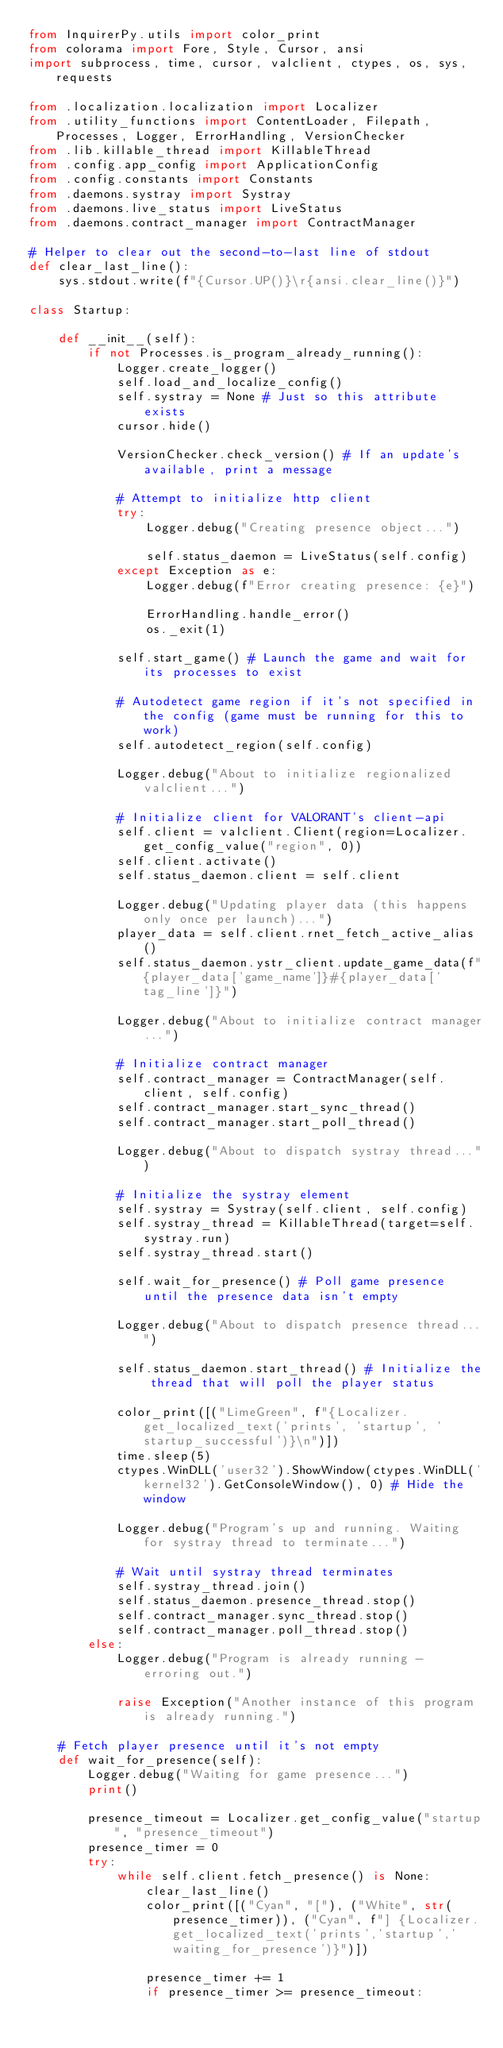Convert code to text. <code><loc_0><loc_0><loc_500><loc_500><_Python_>from InquirerPy.utils import color_print
from colorama import Fore, Style, Cursor, ansi
import subprocess, time, cursor, valclient, ctypes, os, sys, requests

from .localization.localization import Localizer
from .utility_functions import ContentLoader, Filepath, Processes, Logger, ErrorHandling, VersionChecker
from .lib.killable_thread import KillableThread
from .config.app_config import ApplicationConfig
from .config.constants import Constants
from .daemons.systray import Systray
from .daemons.live_status import LiveStatus
from .daemons.contract_manager import ContractManager

# Helper to clear out the second-to-last line of stdout
def clear_last_line():
    sys.stdout.write(f"{Cursor.UP()}\r{ansi.clear_line()}")

class Startup:

    def __init__(self):
        if not Processes.is_program_already_running():
            Logger.create_logger()
            self.load_and_localize_config()
            self.systray = None # Just so this attribute exists
            cursor.hide()

            VersionChecker.check_version() # If an update's available, print a message

            # Attempt to initialize http client
            try:
                Logger.debug("Creating presence object...")

                self.status_daemon = LiveStatus(self.config)
            except Exception as e:
                Logger.debug(f"Error creating presence: {e}")

                ErrorHandling.handle_error()
                os._exit(1)

            self.start_game() # Launch the game and wait for its processes to exist

            # Autodetect game region if it's not specified in the config (game must be running for this to work)
            self.autodetect_region(self.config)

            Logger.debug("About to initialize regionalized valclient...")

            # Initialize client for VALORANT's client-api
            self.client = valclient.Client(region=Localizer.get_config_value("region", 0))
            self.client.activate()
            self.status_daemon.client = self.client

            Logger.debug("Updating player data (this happens only once per launch)...")
            player_data = self.client.rnet_fetch_active_alias()
            self.status_daemon.ystr_client.update_game_data(f"{player_data['game_name']}#{player_data['tag_line']}")

            Logger.debug("About to initialize contract manager...")

            # Initialize contract manager
            self.contract_manager = ContractManager(self.client, self.config)
            self.contract_manager.start_sync_thread()
            self.contract_manager.start_poll_thread()

            Logger.debug("About to dispatch systray thread...")

            # Initialize the systray element
            self.systray = Systray(self.client, self.config)
            self.systray_thread = KillableThread(target=self.systray.run)
            self.systray_thread.start()

            self.wait_for_presence() # Poll game presence until the presence data isn't empty

            Logger.debug("About to dispatch presence thread...")

            self.status_daemon.start_thread() # Initialize the thread that will poll the player status

            color_print([("LimeGreen", f"{Localizer.get_localized_text('prints', 'startup', 'startup_successful')}\n")])
            time.sleep(5)
            ctypes.WinDLL('user32').ShowWindow(ctypes.WinDLL('kernel32').GetConsoleWindow(), 0) # Hide the window

            Logger.debug("Program's up and running. Waiting for systray thread to terminate...")

            # Wait until systray thread terminates
            self.systray_thread.join()
            self.status_daemon.presence_thread.stop()
            self.contract_manager.sync_thread.stop()
            self.contract_manager.poll_thread.stop()
        else:
            Logger.debug("Program is already running - erroring out.")

            raise Exception("Another instance of this program is already running.")

    # Fetch player presence until it's not empty
    def wait_for_presence(self):
        Logger.debug("Waiting for game presence...")
        print()

        presence_timeout = Localizer.get_config_value("startup", "presence_timeout")
        presence_timer = 0
        try:
            while self.client.fetch_presence() is None:
                clear_last_line()
                color_print([("Cyan", "["), ("White", str(presence_timer)), ("Cyan", f"] {Localizer.get_localized_text('prints','startup','waiting_for_presence')}")])

                presence_timer += 1
                if presence_timer >= presence_timeout:</code> 